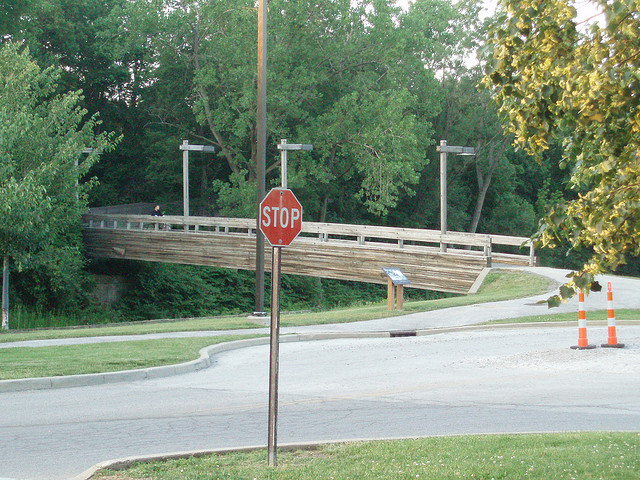Identify and read out the text in this image. STOP 